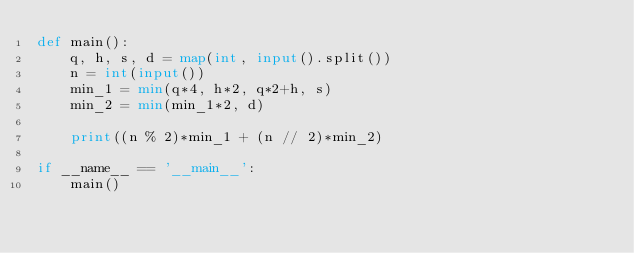<code> <loc_0><loc_0><loc_500><loc_500><_Python_>def main():
    q, h, s, d = map(int, input().split())
    n = int(input())
    min_1 = min(q*4, h*2, q*2+h, s)
    min_2 = min(min_1*2, d)

    print((n % 2)*min_1 + (n // 2)*min_2)

if __name__ == '__main__':
    main()
</code> 